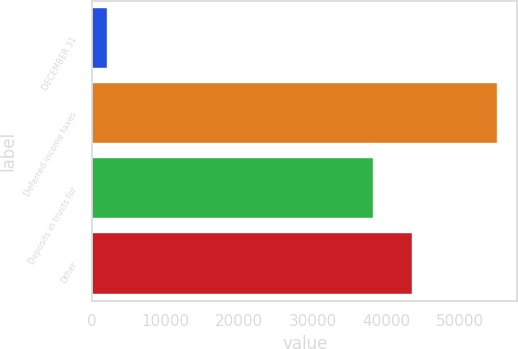Convert chart. <chart><loc_0><loc_0><loc_500><loc_500><bar_chart><fcel>DECEMBER 31<fcel>Deferred income taxes<fcel>Deposits in trusts for<fcel>Other<nl><fcel>2006<fcel>55066<fcel>38229<fcel>43535<nl></chart> 